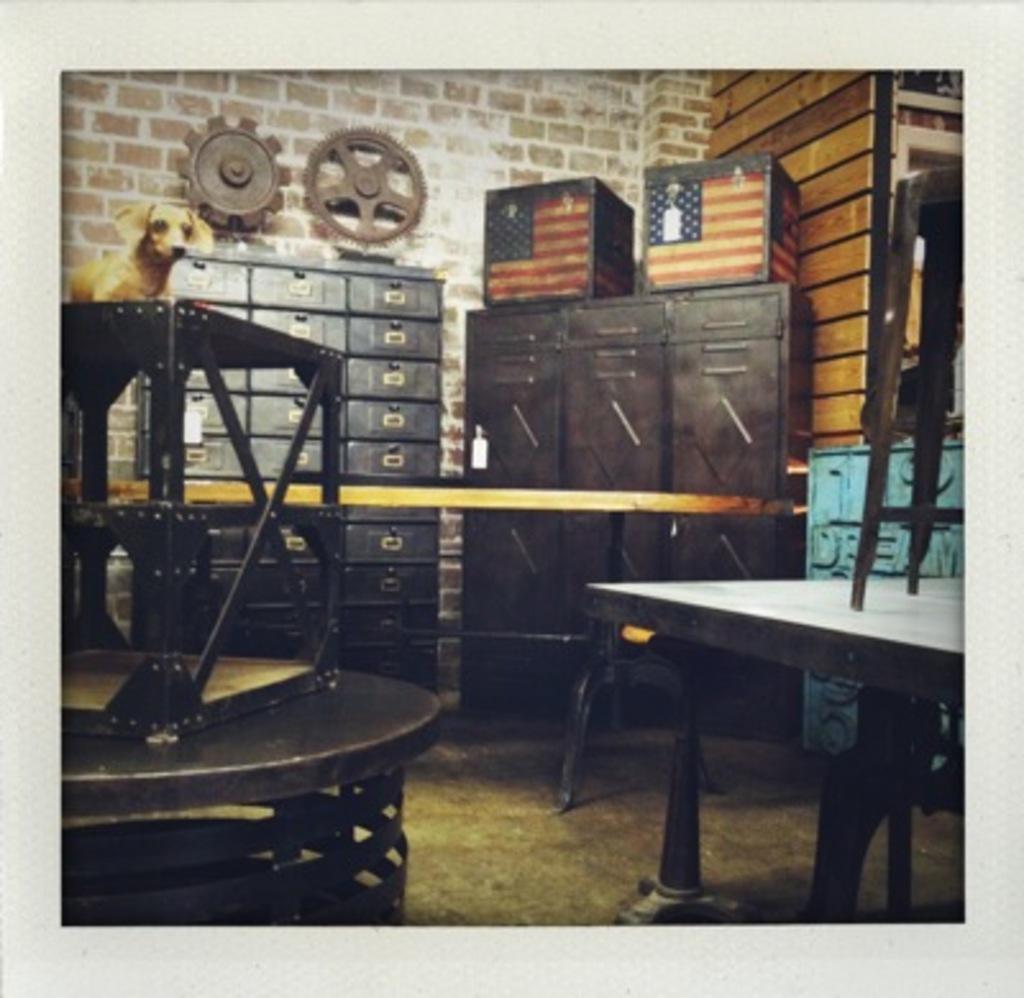How would you summarize this image in a sentence or two? In this image there are furniture in a room, on top there is a dog toy, in the background there is a wall. 